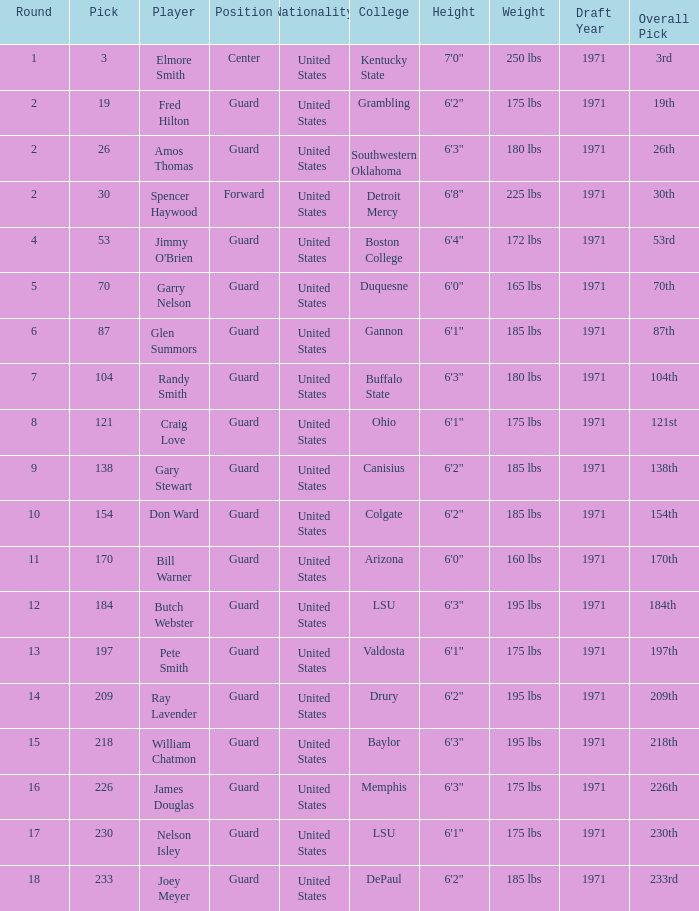WHAT POSITION HAS A ROUND LARGER THAN 2, FOR VALDOSTA COLLEGE? Guard. 